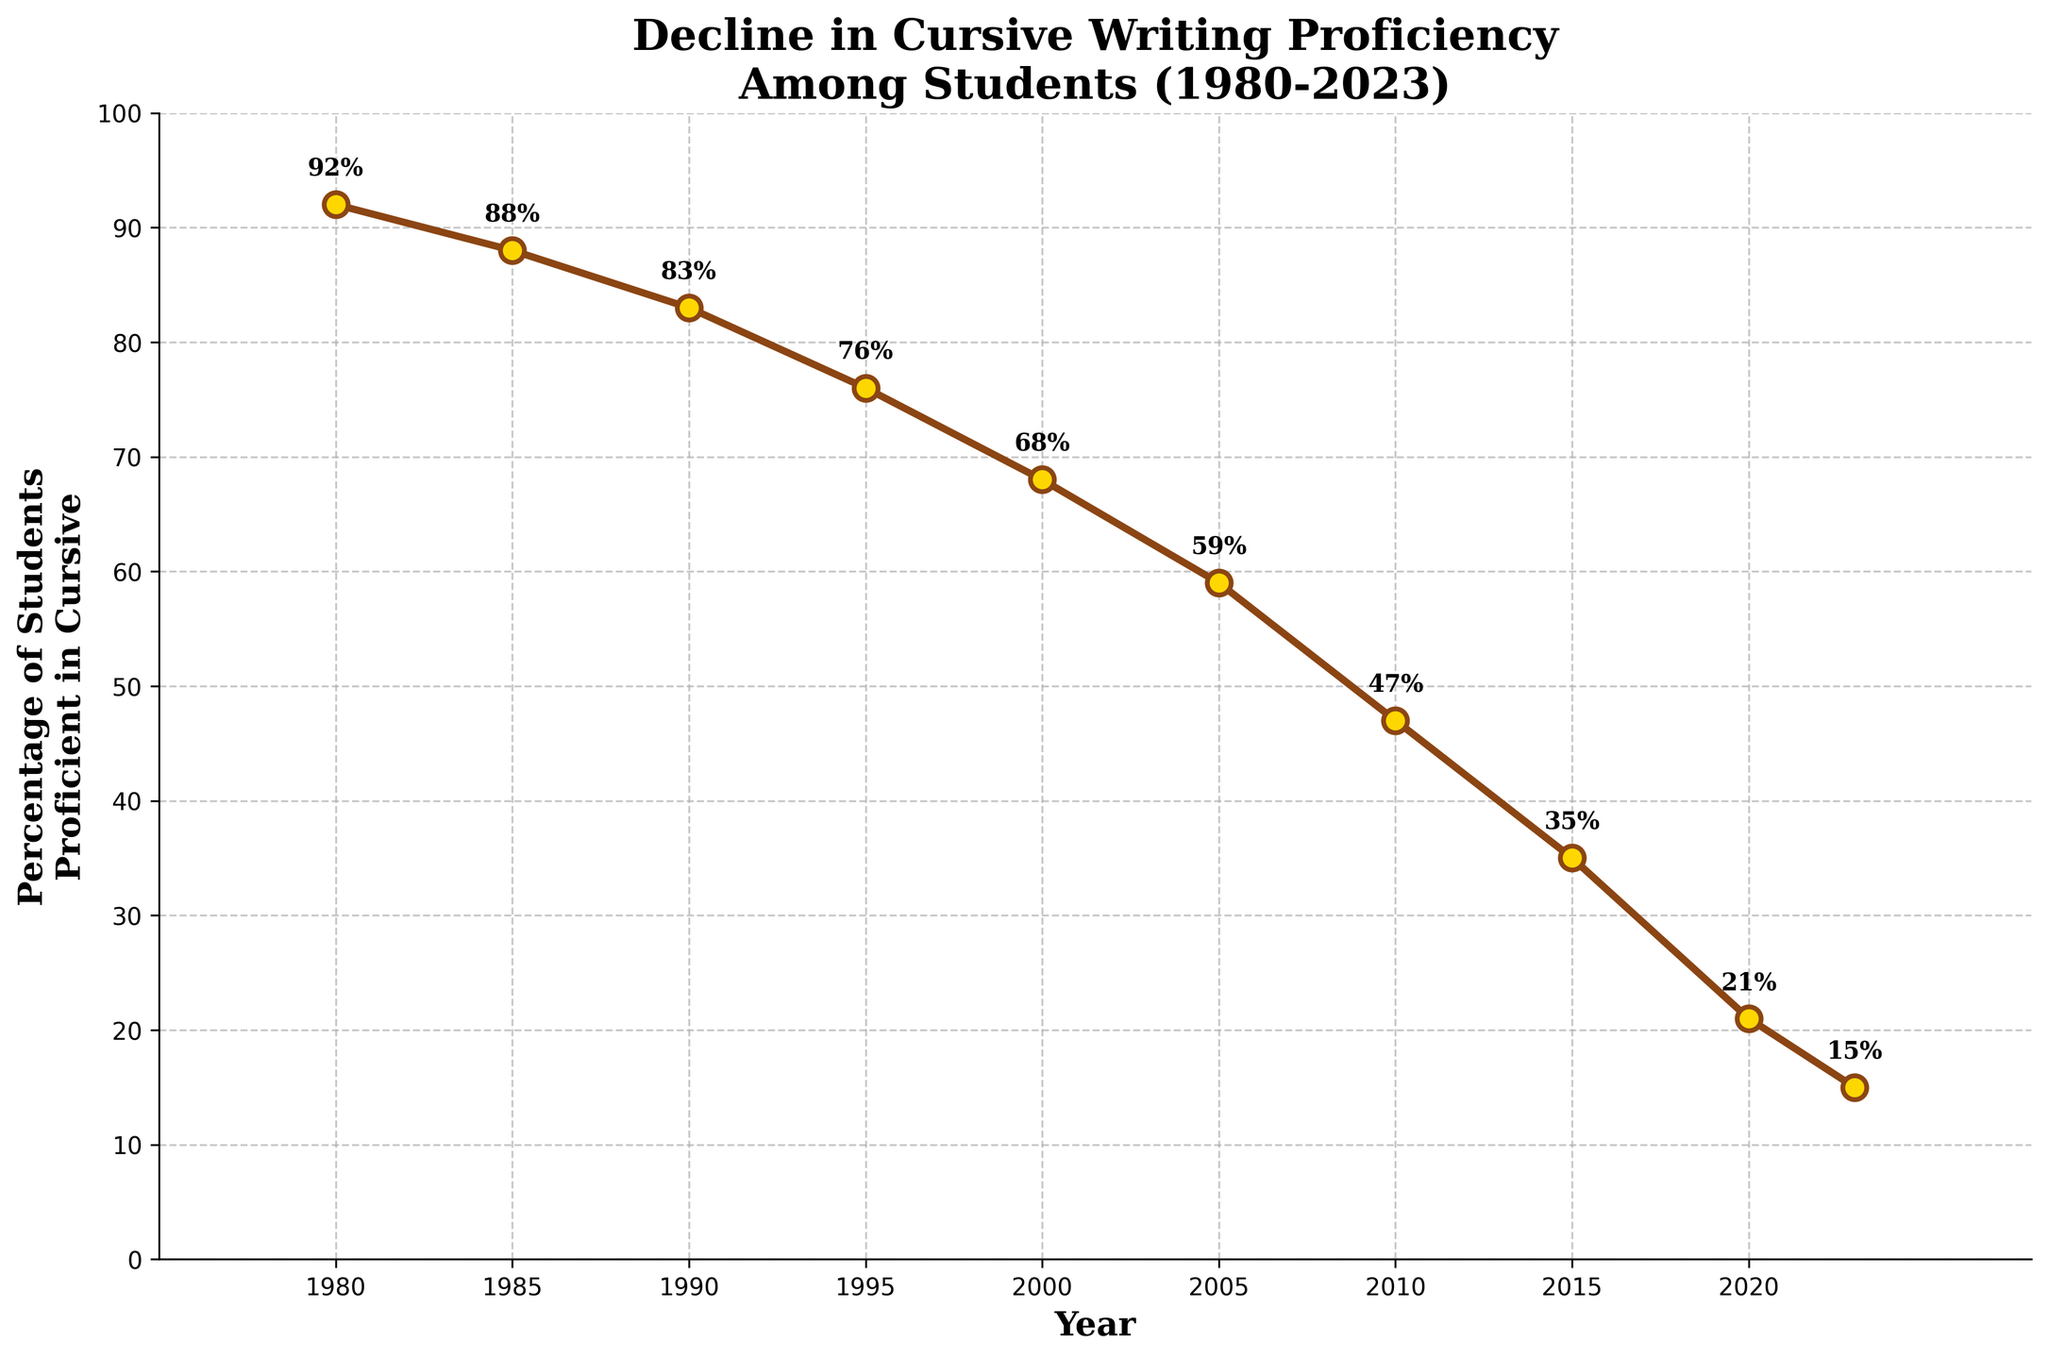What year shows the highest percentage of students proficient in cursive writing? The highest percentage of students proficient in cursive writing is at the peak point of the line chart. This peak occurs at 1980 with 92%.
Answer: 1980 By how many percentage points did the proficiency in cursive writing decline from 1980 to 2000? To find the drop, subtract the proficiency percentage in 2000 from the proficiency percentage in 1980. That is 92% - 68% = 24 percentage points.
Answer: 24 Compare the percentage of students proficient in cursive writing between 2005 and 2010. Which year has a higher percentage? By looking at the data points, in 2005, the percentage is 59%, and in 2010, it is 47%. Therefore, 2005 has a higher percentage compared to 2010.
Answer: 2005 What is the overall trend in the percentage of students proficient in cursive writing from 1980 to 2023? The overall trend shows a continuous decline in the percentage of students proficient in cursive writing from 92% in 1980 to 15% in 2023.
Answer: A continuous decline What is the average percentage of students proficient in cursive writing over the four decades (1980, 1990, 2000, and 2010)? Sum the percentages for these years, then divide by 4: (92 + 83 + 68 + 47) / 4 = 72.5%.
Answer: 72.5% Between which consecutive years was the largest decrease in proficiency observed? Comparing the differences between consecutive years, the largest decrease is between 2005 (59%) and 2010 (47%), which is 12 percentage points (59 - 47 = 12).
Answer: 2005-2010 By what percentage did the proficiency in cursive writing decrease from 1995 to 2023? Subtract the percentage in 2023 from the percentage in 1995: 76% - 15% = 61%.
Answer: 61% If the trend continues, what would you estimate the percentage proficiency to be in 2025? Observing the chart, proficiency declines more significantly in recent years. A rough estimation based on the trend from 2020 to 2023 might lead us to expect a further decrease, possibly below 10% by 2025.
Answer: Possibly below 10% What year recorded a proficiency percentage closest to the average percentage from 1980 to 2023? First, calculate the average over all the given years: (92 + 88 + 83 + 76 + 68 + 59 + 47 + 35 + 21 + 15) / 10 = ~58.4%. The year 2005 recorded 59%, which is the closest to this average.
Answer: 2005 What was the percentage drop from 2015 to 2023? Subtract the 2023 percentage from the 2015 percentage: 35% - 15% = 20%.
Answer: 20 